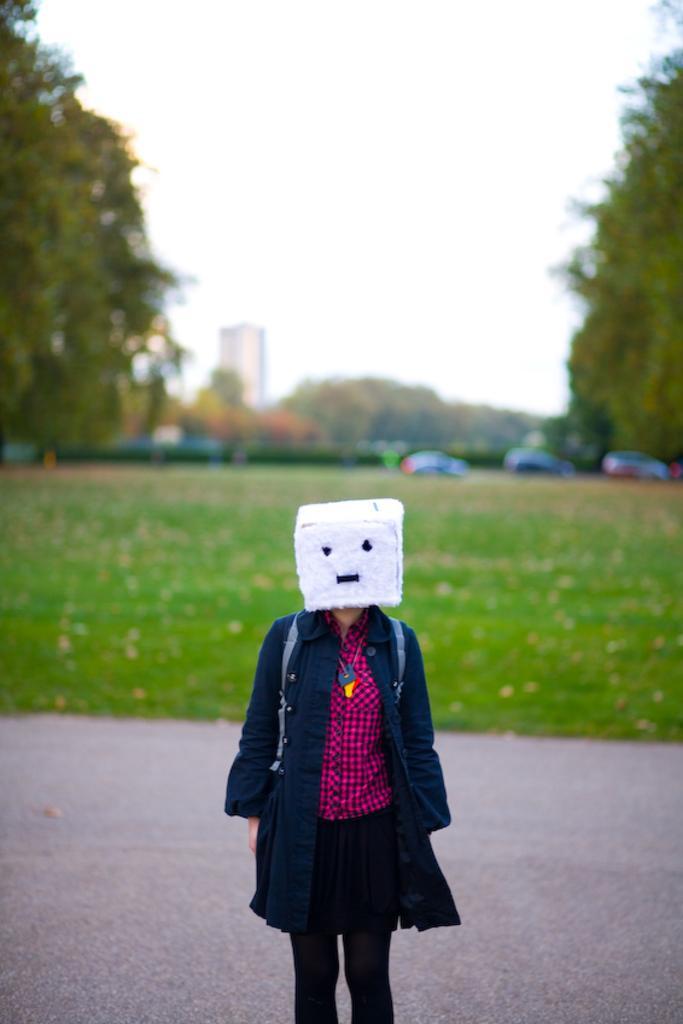How would you summarize this image in a sentence or two? In this picture, we see a person is standing and he or she is wearing a white color mask like thing on her head. At the bottom, we see the road. In the middle, we see the grass and dry leaves. We see the cars moving on the road. On either side of the picture, we see the trees. There are trees and the buildings in the background. At the top, we see the sky. This picture is blurred in the background. 